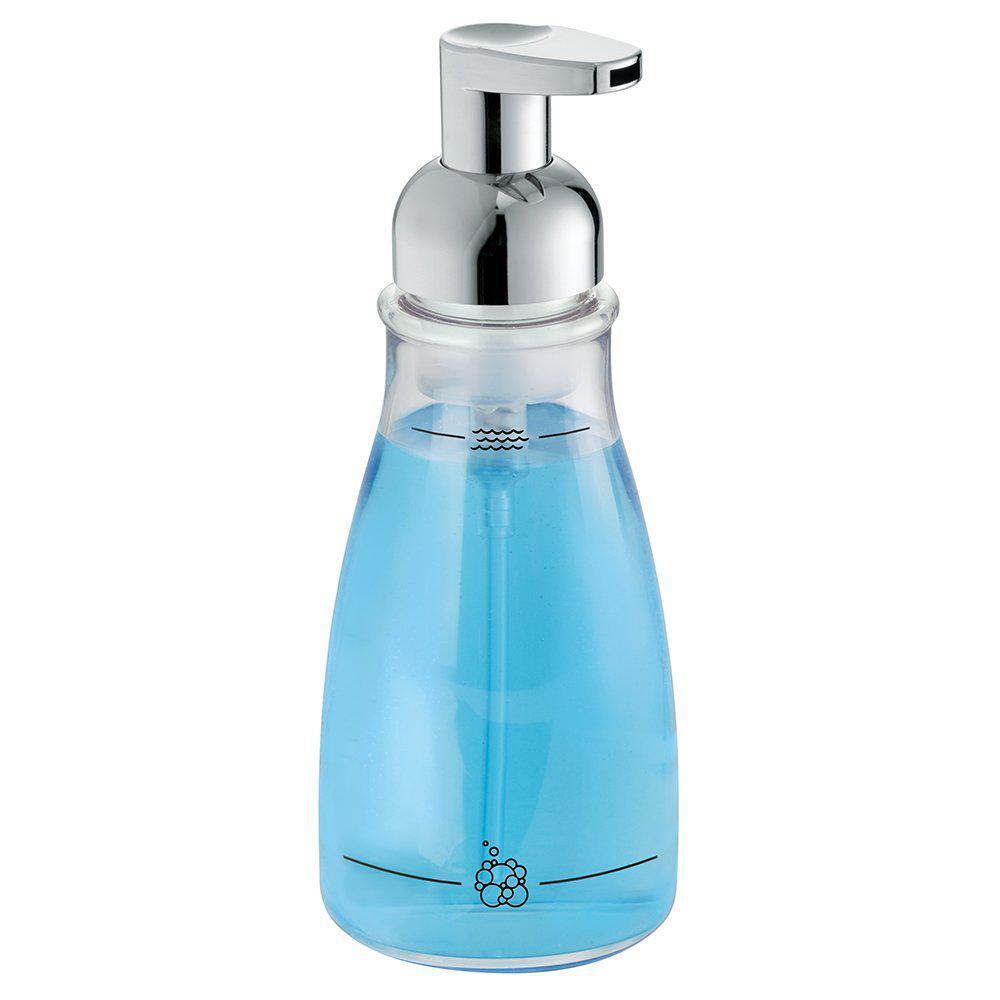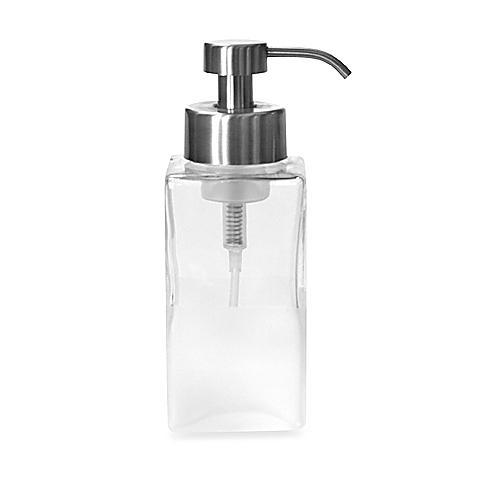The first image is the image on the left, the second image is the image on the right. Assess this claim about the two images: "The soap dispenser in the left image contains blue soap.". Correct or not? Answer yes or no. Yes. The first image is the image on the left, the second image is the image on the right. For the images shown, is this caption "The right image contains a dispenser with a chrome top." true? Answer yes or no. Yes. 